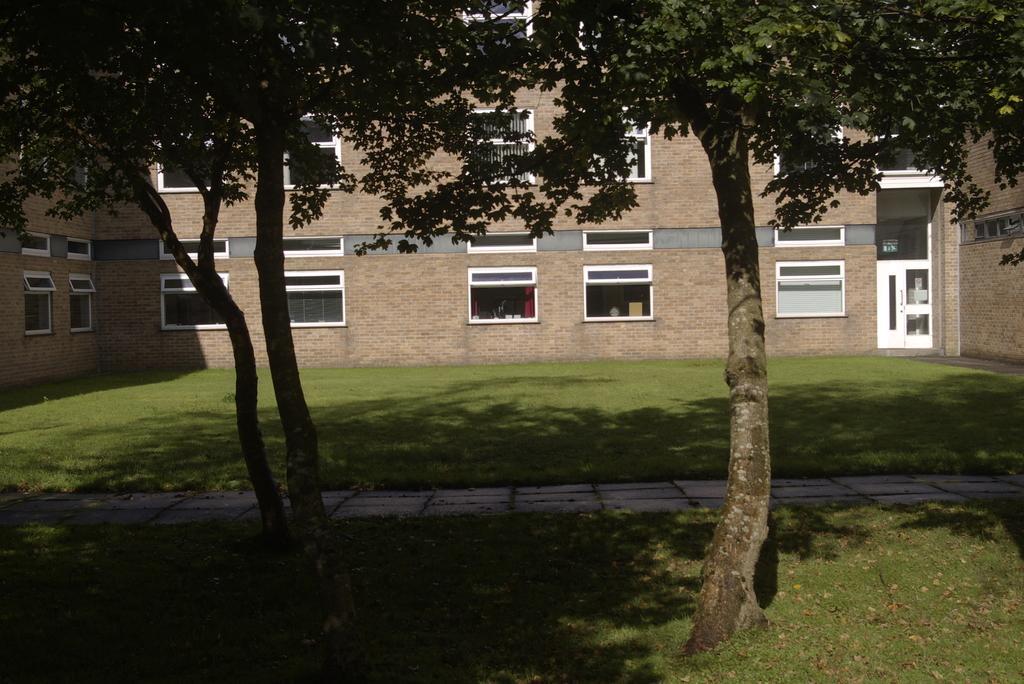Please provide a concise description of this image. In the picture we can see a grass surface on it we can see two trees and behind it we can see a path and behind it we can again see a grass surface and a building wall with windows and door and a person standing behind it. 